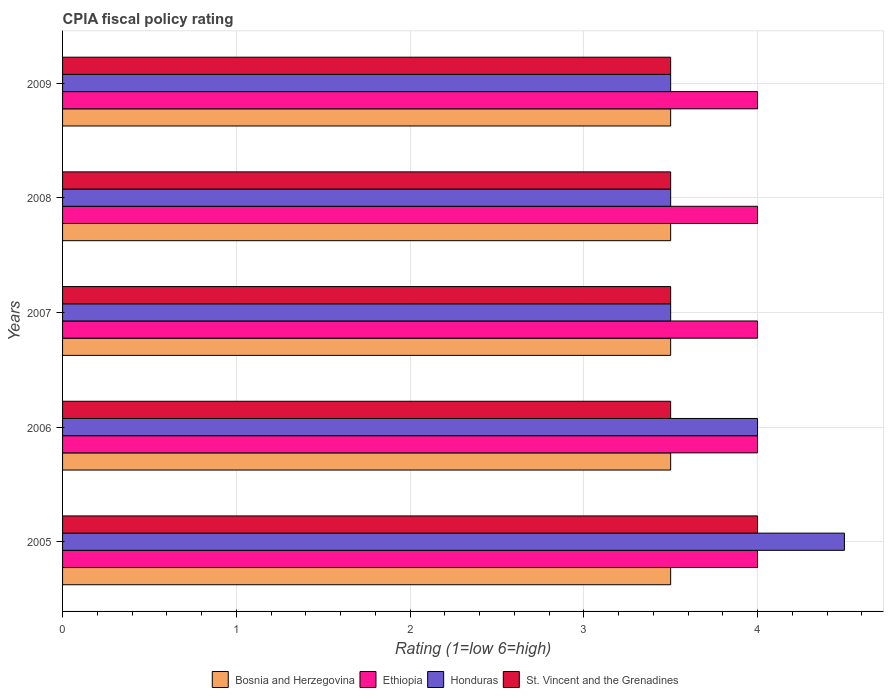How many groups of bars are there?
Your response must be concise. 5. Are the number of bars per tick equal to the number of legend labels?
Your answer should be compact. Yes. Are the number of bars on each tick of the Y-axis equal?
Make the answer very short. Yes. How many bars are there on the 5th tick from the bottom?
Give a very brief answer. 4. What is the label of the 1st group of bars from the top?
Offer a terse response. 2009. In how many cases, is the number of bars for a given year not equal to the number of legend labels?
Your response must be concise. 0. Across all years, what is the maximum CPIA rating in Ethiopia?
Provide a succinct answer. 4. Across all years, what is the minimum CPIA rating in St. Vincent and the Grenadines?
Your answer should be compact. 3.5. In which year was the CPIA rating in Honduras maximum?
Ensure brevity in your answer.  2005. In which year was the CPIA rating in Ethiopia minimum?
Provide a short and direct response. 2005. What is the total CPIA rating in St. Vincent and the Grenadines in the graph?
Ensure brevity in your answer.  18. What is the difference between the CPIA rating in Honduras in 2007 and that in 2009?
Your response must be concise. 0. What is the ratio of the CPIA rating in Ethiopia in 2006 to that in 2007?
Give a very brief answer. 1. In how many years, is the CPIA rating in Bosnia and Herzegovina greater than the average CPIA rating in Bosnia and Herzegovina taken over all years?
Your answer should be compact. 0. Is the sum of the CPIA rating in St. Vincent and the Grenadines in 2006 and 2007 greater than the maximum CPIA rating in Ethiopia across all years?
Your answer should be very brief. Yes. Is it the case that in every year, the sum of the CPIA rating in St. Vincent and the Grenadines and CPIA rating in Bosnia and Herzegovina is greater than the sum of CPIA rating in Ethiopia and CPIA rating in Honduras?
Keep it short and to the point. No. What does the 3rd bar from the top in 2006 represents?
Keep it short and to the point. Ethiopia. What does the 4th bar from the bottom in 2005 represents?
Make the answer very short. St. Vincent and the Grenadines. Is it the case that in every year, the sum of the CPIA rating in Ethiopia and CPIA rating in St. Vincent and the Grenadines is greater than the CPIA rating in Bosnia and Herzegovina?
Your answer should be compact. Yes. How many bars are there?
Your answer should be very brief. 20. How many years are there in the graph?
Your answer should be very brief. 5. Are the values on the major ticks of X-axis written in scientific E-notation?
Your answer should be very brief. No. How are the legend labels stacked?
Offer a very short reply. Horizontal. What is the title of the graph?
Your answer should be compact. CPIA fiscal policy rating. What is the Rating (1=low 6=high) in Bosnia and Herzegovina in 2006?
Your answer should be very brief. 3.5. What is the Rating (1=low 6=high) in Honduras in 2006?
Your answer should be compact. 4. What is the Rating (1=low 6=high) of St. Vincent and the Grenadines in 2006?
Your answer should be very brief. 3.5. What is the Rating (1=low 6=high) in St. Vincent and the Grenadines in 2007?
Your answer should be very brief. 3.5. What is the Rating (1=low 6=high) of Honduras in 2008?
Provide a succinct answer. 3.5. What is the Rating (1=low 6=high) in St. Vincent and the Grenadines in 2008?
Provide a short and direct response. 3.5. What is the Rating (1=low 6=high) of Bosnia and Herzegovina in 2009?
Ensure brevity in your answer.  3.5. What is the Rating (1=low 6=high) of Ethiopia in 2009?
Provide a succinct answer. 4. Across all years, what is the maximum Rating (1=low 6=high) of Bosnia and Herzegovina?
Your response must be concise. 3.5. Across all years, what is the maximum Rating (1=low 6=high) in Honduras?
Make the answer very short. 4.5. Across all years, what is the minimum Rating (1=low 6=high) in Ethiopia?
Your response must be concise. 4. What is the total Rating (1=low 6=high) in Ethiopia in the graph?
Provide a short and direct response. 20. What is the total Rating (1=low 6=high) in Honduras in the graph?
Ensure brevity in your answer.  19. What is the total Rating (1=low 6=high) in St. Vincent and the Grenadines in the graph?
Ensure brevity in your answer.  18. What is the difference between the Rating (1=low 6=high) in Ethiopia in 2005 and that in 2006?
Provide a short and direct response. 0. What is the difference between the Rating (1=low 6=high) in Honduras in 2005 and that in 2006?
Your answer should be very brief. 0.5. What is the difference between the Rating (1=low 6=high) of St. Vincent and the Grenadines in 2005 and that in 2006?
Offer a very short reply. 0.5. What is the difference between the Rating (1=low 6=high) of Honduras in 2005 and that in 2008?
Your answer should be very brief. 1. What is the difference between the Rating (1=low 6=high) in St. Vincent and the Grenadines in 2005 and that in 2008?
Your answer should be very brief. 0.5. What is the difference between the Rating (1=low 6=high) of Ethiopia in 2005 and that in 2009?
Your answer should be very brief. 0. What is the difference between the Rating (1=low 6=high) of Honduras in 2005 and that in 2009?
Provide a short and direct response. 1. What is the difference between the Rating (1=low 6=high) of Honduras in 2006 and that in 2008?
Keep it short and to the point. 0.5. What is the difference between the Rating (1=low 6=high) in Ethiopia in 2007 and that in 2008?
Provide a succinct answer. 0. What is the difference between the Rating (1=low 6=high) of Honduras in 2007 and that in 2008?
Give a very brief answer. 0. What is the difference between the Rating (1=low 6=high) in Bosnia and Herzegovina in 2008 and that in 2009?
Your response must be concise. 0. What is the difference between the Rating (1=low 6=high) in Ethiopia in 2008 and that in 2009?
Ensure brevity in your answer.  0. What is the difference between the Rating (1=low 6=high) of Honduras in 2008 and that in 2009?
Ensure brevity in your answer.  0. What is the difference between the Rating (1=low 6=high) in Bosnia and Herzegovina in 2005 and the Rating (1=low 6=high) in Ethiopia in 2006?
Provide a short and direct response. -0.5. What is the difference between the Rating (1=low 6=high) in Bosnia and Herzegovina in 2005 and the Rating (1=low 6=high) in Honduras in 2006?
Your answer should be compact. -0.5. What is the difference between the Rating (1=low 6=high) of Bosnia and Herzegovina in 2005 and the Rating (1=low 6=high) of St. Vincent and the Grenadines in 2006?
Provide a short and direct response. 0. What is the difference between the Rating (1=low 6=high) in Ethiopia in 2005 and the Rating (1=low 6=high) in Honduras in 2006?
Give a very brief answer. 0. What is the difference between the Rating (1=low 6=high) of Bosnia and Herzegovina in 2005 and the Rating (1=low 6=high) of Ethiopia in 2007?
Give a very brief answer. -0.5. What is the difference between the Rating (1=low 6=high) of Bosnia and Herzegovina in 2005 and the Rating (1=low 6=high) of St. Vincent and the Grenadines in 2007?
Offer a very short reply. 0. What is the difference between the Rating (1=low 6=high) in Ethiopia in 2005 and the Rating (1=low 6=high) in Honduras in 2007?
Provide a short and direct response. 0.5. What is the difference between the Rating (1=low 6=high) of Ethiopia in 2005 and the Rating (1=low 6=high) of St. Vincent and the Grenadines in 2007?
Provide a succinct answer. 0.5. What is the difference between the Rating (1=low 6=high) of Bosnia and Herzegovina in 2005 and the Rating (1=low 6=high) of Ethiopia in 2008?
Your answer should be compact. -0.5. What is the difference between the Rating (1=low 6=high) in Honduras in 2005 and the Rating (1=low 6=high) in St. Vincent and the Grenadines in 2008?
Offer a very short reply. 1. What is the difference between the Rating (1=low 6=high) of Bosnia and Herzegovina in 2005 and the Rating (1=low 6=high) of Ethiopia in 2009?
Ensure brevity in your answer.  -0.5. What is the difference between the Rating (1=low 6=high) of Bosnia and Herzegovina in 2005 and the Rating (1=low 6=high) of Honduras in 2009?
Provide a succinct answer. 0. What is the difference between the Rating (1=low 6=high) of Honduras in 2005 and the Rating (1=low 6=high) of St. Vincent and the Grenadines in 2009?
Offer a terse response. 1. What is the difference between the Rating (1=low 6=high) of Bosnia and Herzegovina in 2006 and the Rating (1=low 6=high) of Ethiopia in 2007?
Your answer should be compact. -0.5. What is the difference between the Rating (1=low 6=high) of Bosnia and Herzegovina in 2006 and the Rating (1=low 6=high) of Honduras in 2007?
Make the answer very short. 0. What is the difference between the Rating (1=low 6=high) in Ethiopia in 2006 and the Rating (1=low 6=high) in Honduras in 2007?
Offer a very short reply. 0.5. What is the difference between the Rating (1=low 6=high) in Bosnia and Herzegovina in 2006 and the Rating (1=low 6=high) in Honduras in 2008?
Provide a short and direct response. 0. What is the difference between the Rating (1=low 6=high) of Honduras in 2006 and the Rating (1=low 6=high) of St. Vincent and the Grenadines in 2008?
Offer a terse response. 0.5. What is the difference between the Rating (1=low 6=high) of Bosnia and Herzegovina in 2006 and the Rating (1=low 6=high) of Ethiopia in 2009?
Provide a succinct answer. -0.5. What is the difference between the Rating (1=low 6=high) of Bosnia and Herzegovina in 2006 and the Rating (1=low 6=high) of Honduras in 2009?
Provide a succinct answer. 0. What is the difference between the Rating (1=low 6=high) in Honduras in 2006 and the Rating (1=low 6=high) in St. Vincent and the Grenadines in 2009?
Make the answer very short. 0.5. What is the difference between the Rating (1=low 6=high) in Ethiopia in 2007 and the Rating (1=low 6=high) in St. Vincent and the Grenadines in 2008?
Provide a short and direct response. 0.5. What is the difference between the Rating (1=low 6=high) of Bosnia and Herzegovina in 2007 and the Rating (1=low 6=high) of Ethiopia in 2009?
Make the answer very short. -0.5. What is the difference between the Rating (1=low 6=high) in Ethiopia in 2007 and the Rating (1=low 6=high) in Honduras in 2009?
Make the answer very short. 0.5. What is the difference between the Rating (1=low 6=high) of Honduras in 2007 and the Rating (1=low 6=high) of St. Vincent and the Grenadines in 2009?
Offer a terse response. 0. What is the difference between the Rating (1=low 6=high) in Bosnia and Herzegovina in 2008 and the Rating (1=low 6=high) in Ethiopia in 2009?
Give a very brief answer. -0.5. What is the difference between the Rating (1=low 6=high) in Ethiopia in 2008 and the Rating (1=low 6=high) in Honduras in 2009?
Provide a succinct answer. 0.5. What is the difference between the Rating (1=low 6=high) in Ethiopia in 2008 and the Rating (1=low 6=high) in St. Vincent and the Grenadines in 2009?
Your response must be concise. 0.5. What is the difference between the Rating (1=low 6=high) of Honduras in 2008 and the Rating (1=low 6=high) of St. Vincent and the Grenadines in 2009?
Offer a terse response. 0. What is the average Rating (1=low 6=high) of Bosnia and Herzegovina per year?
Provide a succinct answer. 3.5. What is the average Rating (1=low 6=high) in Ethiopia per year?
Provide a short and direct response. 4. What is the average Rating (1=low 6=high) in St. Vincent and the Grenadines per year?
Provide a succinct answer. 3.6. In the year 2005, what is the difference between the Rating (1=low 6=high) of Honduras and Rating (1=low 6=high) of St. Vincent and the Grenadines?
Your answer should be very brief. 0.5. In the year 2006, what is the difference between the Rating (1=low 6=high) in Bosnia and Herzegovina and Rating (1=low 6=high) in Honduras?
Your response must be concise. -0.5. In the year 2006, what is the difference between the Rating (1=low 6=high) of Bosnia and Herzegovina and Rating (1=low 6=high) of St. Vincent and the Grenadines?
Make the answer very short. 0. In the year 2006, what is the difference between the Rating (1=low 6=high) in Ethiopia and Rating (1=low 6=high) in Honduras?
Offer a terse response. 0. In the year 2006, what is the difference between the Rating (1=low 6=high) in Honduras and Rating (1=low 6=high) in St. Vincent and the Grenadines?
Give a very brief answer. 0.5. In the year 2007, what is the difference between the Rating (1=low 6=high) of Bosnia and Herzegovina and Rating (1=low 6=high) of Honduras?
Keep it short and to the point. 0. In the year 2007, what is the difference between the Rating (1=low 6=high) in Honduras and Rating (1=low 6=high) in St. Vincent and the Grenadines?
Provide a short and direct response. 0. In the year 2008, what is the difference between the Rating (1=low 6=high) of Bosnia and Herzegovina and Rating (1=low 6=high) of St. Vincent and the Grenadines?
Give a very brief answer. 0. In the year 2008, what is the difference between the Rating (1=low 6=high) in Ethiopia and Rating (1=low 6=high) in St. Vincent and the Grenadines?
Give a very brief answer. 0.5. In the year 2008, what is the difference between the Rating (1=low 6=high) in Honduras and Rating (1=low 6=high) in St. Vincent and the Grenadines?
Give a very brief answer. 0. In the year 2009, what is the difference between the Rating (1=low 6=high) of Bosnia and Herzegovina and Rating (1=low 6=high) of St. Vincent and the Grenadines?
Ensure brevity in your answer.  0. In the year 2009, what is the difference between the Rating (1=low 6=high) of Ethiopia and Rating (1=low 6=high) of Honduras?
Your answer should be very brief. 0.5. In the year 2009, what is the difference between the Rating (1=low 6=high) in Ethiopia and Rating (1=low 6=high) in St. Vincent and the Grenadines?
Ensure brevity in your answer.  0.5. What is the ratio of the Rating (1=low 6=high) in Bosnia and Herzegovina in 2005 to that in 2006?
Make the answer very short. 1. What is the ratio of the Rating (1=low 6=high) in St. Vincent and the Grenadines in 2005 to that in 2006?
Keep it short and to the point. 1.14. What is the ratio of the Rating (1=low 6=high) in Ethiopia in 2005 to that in 2007?
Offer a terse response. 1. What is the ratio of the Rating (1=low 6=high) in Honduras in 2005 to that in 2007?
Provide a short and direct response. 1.29. What is the ratio of the Rating (1=low 6=high) in St. Vincent and the Grenadines in 2005 to that in 2007?
Your answer should be compact. 1.14. What is the ratio of the Rating (1=low 6=high) of Bosnia and Herzegovina in 2005 to that in 2008?
Your response must be concise. 1. What is the ratio of the Rating (1=low 6=high) in Ethiopia in 2005 to that in 2008?
Provide a short and direct response. 1. What is the ratio of the Rating (1=low 6=high) in St. Vincent and the Grenadines in 2005 to that in 2008?
Make the answer very short. 1.14. What is the ratio of the Rating (1=low 6=high) in Bosnia and Herzegovina in 2005 to that in 2009?
Make the answer very short. 1. What is the ratio of the Rating (1=low 6=high) of Ethiopia in 2005 to that in 2009?
Keep it short and to the point. 1. What is the ratio of the Rating (1=low 6=high) in Bosnia and Herzegovina in 2006 to that in 2008?
Your answer should be compact. 1. What is the ratio of the Rating (1=low 6=high) of Ethiopia in 2006 to that in 2008?
Make the answer very short. 1. What is the ratio of the Rating (1=low 6=high) in Honduras in 2006 to that in 2008?
Offer a terse response. 1.14. What is the ratio of the Rating (1=low 6=high) in St. Vincent and the Grenadines in 2006 to that in 2008?
Your response must be concise. 1. What is the ratio of the Rating (1=low 6=high) in Ethiopia in 2006 to that in 2009?
Offer a very short reply. 1. What is the ratio of the Rating (1=low 6=high) of Honduras in 2006 to that in 2009?
Make the answer very short. 1.14. What is the ratio of the Rating (1=low 6=high) in Honduras in 2007 to that in 2008?
Give a very brief answer. 1. What is the ratio of the Rating (1=low 6=high) of St. Vincent and the Grenadines in 2007 to that in 2008?
Offer a terse response. 1. What is the ratio of the Rating (1=low 6=high) of Bosnia and Herzegovina in 2007 to that in 2009?
Offer a terse response. 1. What is the ratio of the Rating (1=low 6=high) in Honduras in 2007 to that in 2009?
Keep it short and to the point. 1. What is the ratio of the Rating (1=low 6=high) of St. Vincent and the Grenadines in 2007 to that in 2009?
Provide a short and direct response. 1. What is the ratio of the Rating (1=low 6=high) in Bosnia and Herzegovina in 2008 to that in 2009?
Offer a very short reply. 1. What is the ratio of the Rating (1=low 6=high) of Ethiopia in 2008 to that in 2009?
Provide a succinct answer. 1. What is the ratio of the Rating (1=low 6=high) of Honduras in 2008 to that in 2009?
Your answer should be compact. 1. What is the ratio of the Rating (1=low 6=high) in St. Vincent and the Grenadines in 2008 to that in 2009?
Make the answer very short. 1. What is the difference between the highest and the second highest Rating (1=low 6=high) in Honduras?
Your answer should be very brief. 0.5. What is the difference between the highest and the second highest Rating (1=low 6=high) of St. Vincent and the Grenadines?
Your response must be concise. 0.5. What is the difference between the highest and the lowest Rating (1=low 6=high) of St. Vincent and the Grenadines?
Provide a succinct answer. 0.5. 